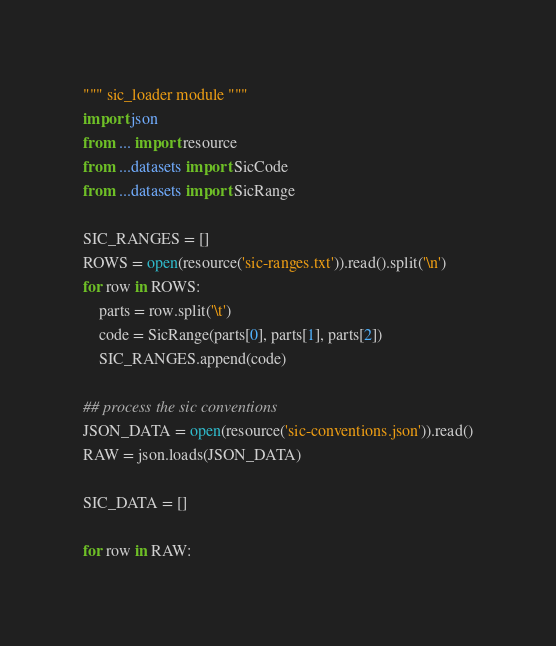Convert code to text. <code><loc_0><loc_0><loc_500><loc_500><_Python_>""" sic_loader module """
import json
from ... import resource
from ...datasets import SicCode
from ...datasets import SicRange

SIC_RANGES = []
ROWS = open(resource('sic-ranges.txt')).read().split('\n')
for row in ROWS:
    parts = row.split('\t')
    code = SicRange(parts[0], parts[1], parts[2])
    SIC_RANGES.append(code)

## process the sic conventions
JSON_DATA = open(resource('sic-conventions.json')).read()
RAW = json.loads(JSON_DATA)

SIC_DATA = []

for row in RAW:</code> 